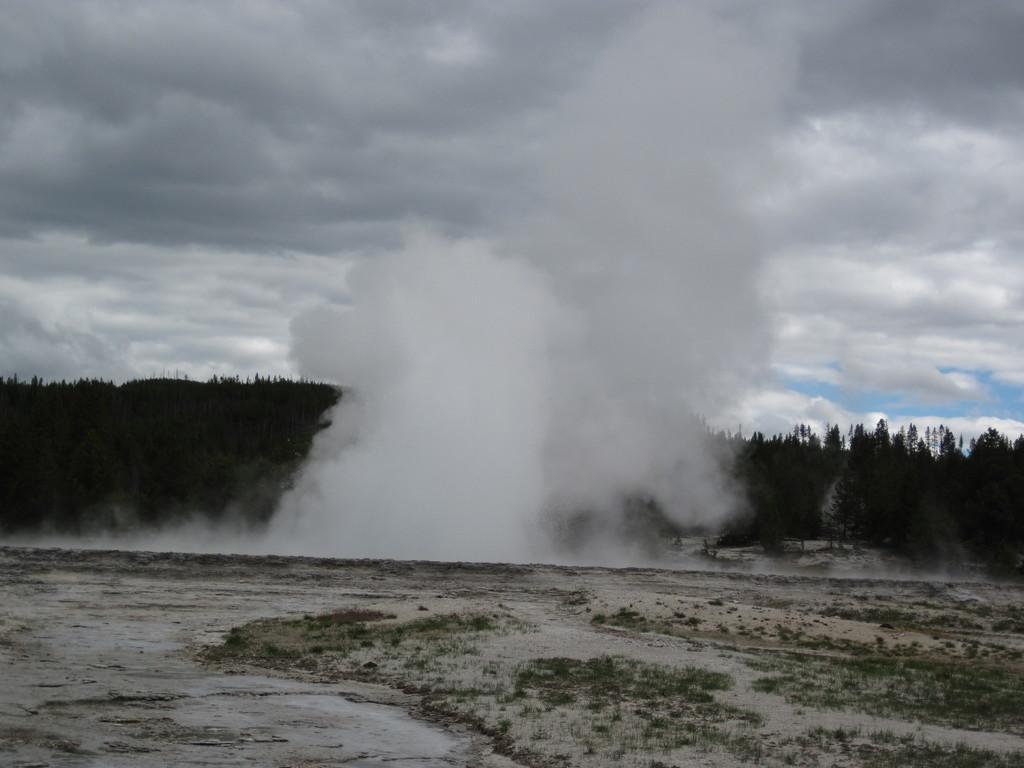Can you describe this image briefly? In this picture I can see smoke, there are trees, and in the background there is the sky. 